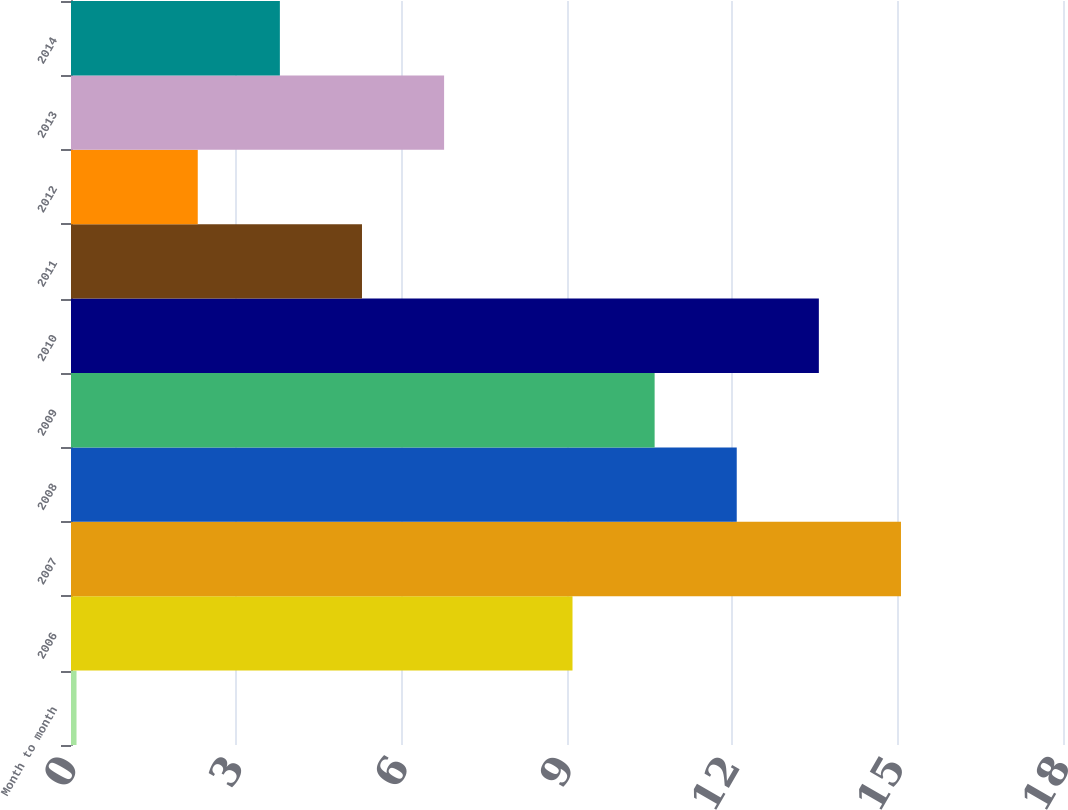Convert chart. <chart><loc_0><loc_0><loc_500><loc_500><bar_chart><fcel>Month to month<fcel>2006<fcel>2007<fcel>2008<fcel>2009<fcel>2010<fcel>2011<fcel>2012<fcel>2013<fcel>2014<nl><fcel>0.1<fcel>9.1<fcel>15.06<fcel>12.08<fcel>10.59<fcel>13.57<fcel>5.28<fcel>2.3<fcel>6.77<fcel>3.79<nl></chart> 